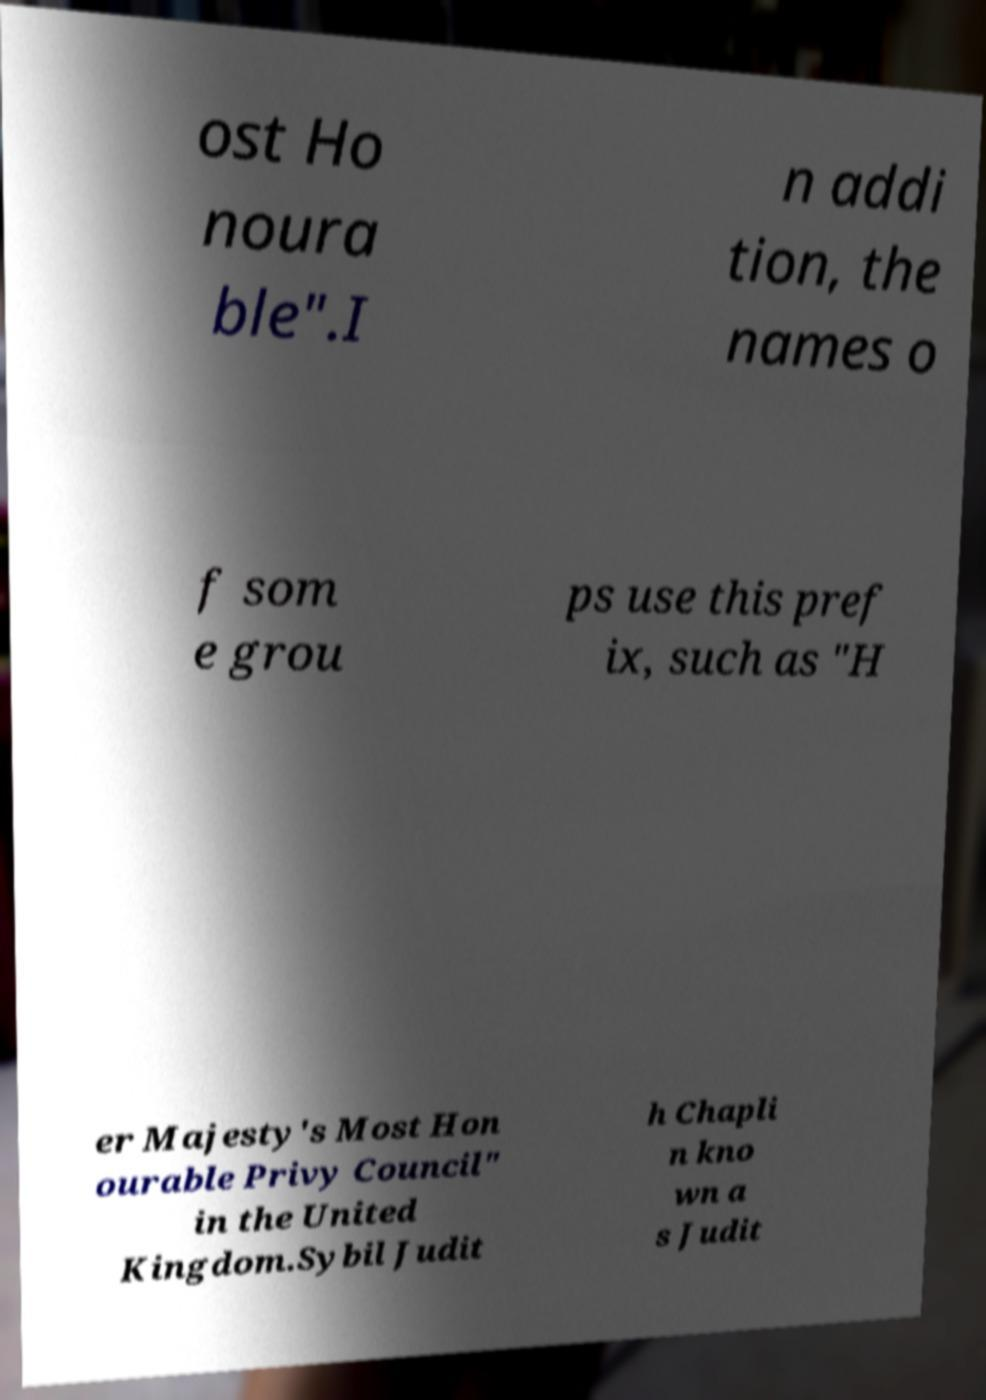Can you read and provide the text displayed in the image?This photo seems to have some interesting text. Can you extract and type it out for me? ost Ho noura ble".I n addi tion, the names o f som e grou ps use this pref ix, such as "H er Majesty's Most Hon ourable Privy Council" in the United Kingdom.Sybil Judit h Chapli n kno wn a s Judit 